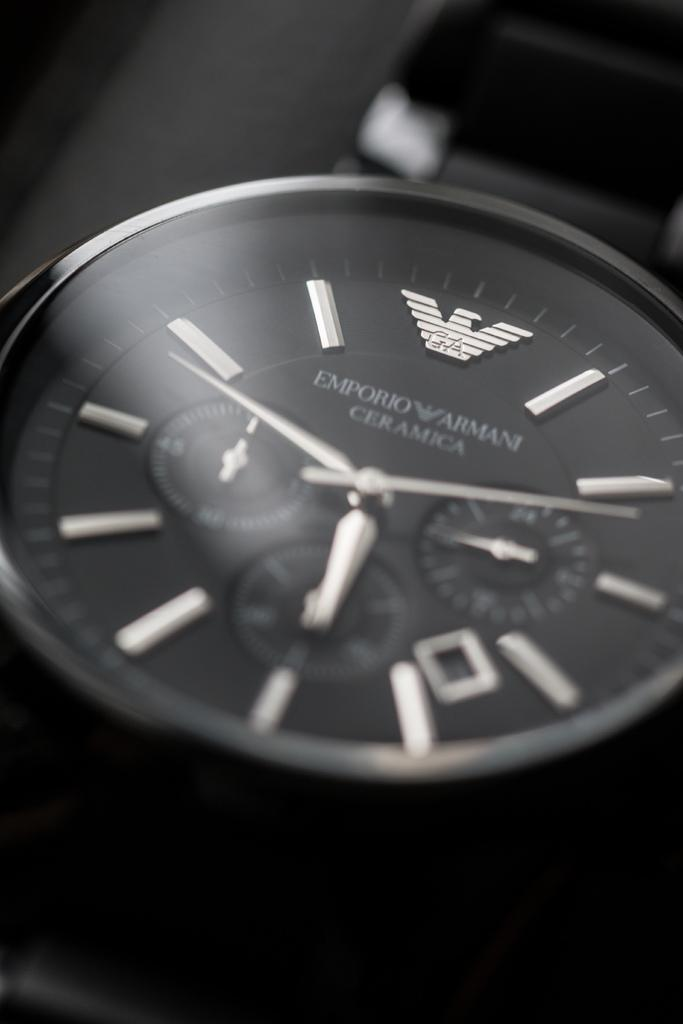<image>
Create a compact narrative representing the image presented. A black and silver watch with Emporio Armani Ceramica on it. 